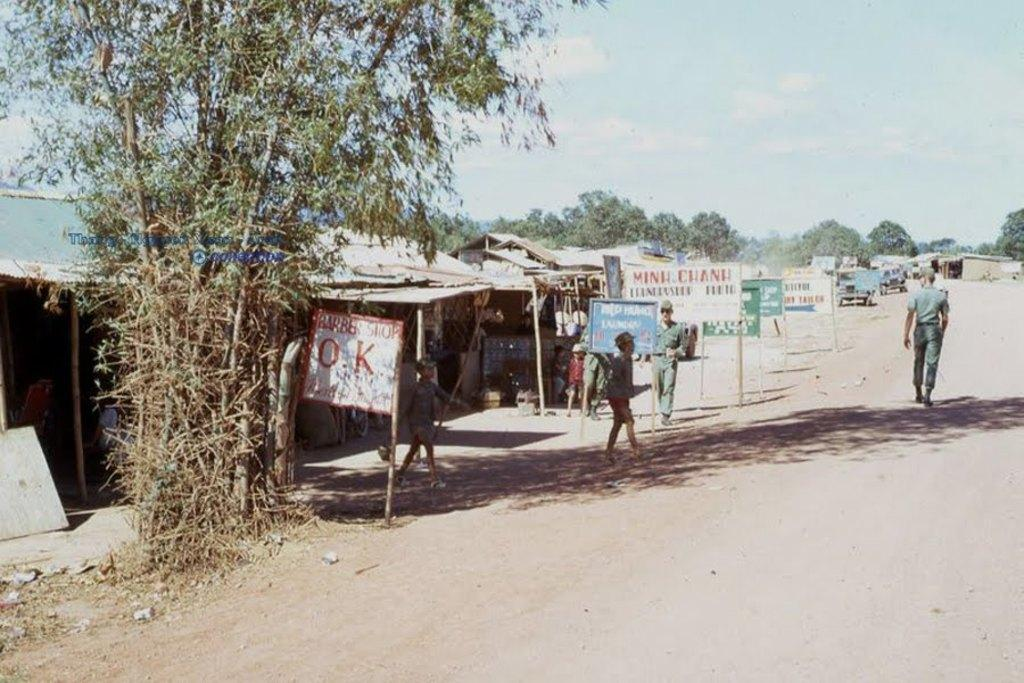What type of structures can be seen in the image? There are houses in the image. What other natural elements are present in the image? There are trees in the image. What type of man-made objects can be seen in the image? There are vehicles in the image. Can you describe the people in the image? There is a group of people in the image. How many vehicles are visible in the image? There are more vehicles in the image. What can be seen in the background of the image? There are clouds visible in the background of the image. What is the purpose of the bomb in the image? There is no bomb present in the image. What type of skin is visible on the people in the image? The image does not provide enough detail to determine the type of skin of the people in the image. 